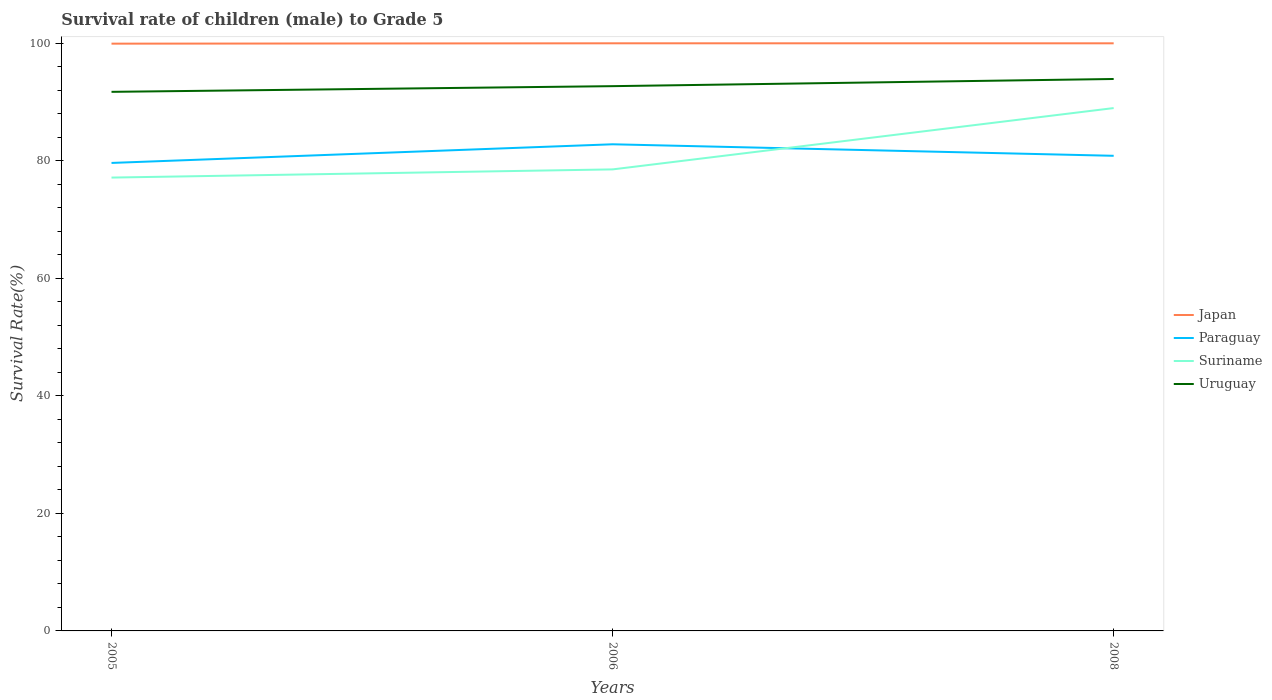How many different coloured lines are there?
Provide a succinct answer. 4. Does the line corresponding to Uruguay intersect with the line corresponding to Japan?
Make the answer very short. No. Is the number of lines equal to the number of legend labels?
Ensure brevity in your answer.  Yes. Across all years, what is the maximum survival rate of male children to grade 5 in Uruguay?
Your answer should be compact. 91.73. In which year was the survival rate of male children to grade 5 in Japan maximum?
Your response must be concise. 2005. What is the total survival rate of male children to grade 5 in Japan in the graph?
Provide a succinct answer. -0.06. What is the difference between the highest and the second highest survival rate of male children to grade 5 in Suriname?
Ensure brevity in your answer.  11.83. What is the difference between the highest and the lowest survival rate of male children to grade 5 in Uruguay?
Provide a succinct answer. 1. Are the values on the major ticks of Y-axis written in scientific E-notation?
Make the answer very short. No. Does the graph contain any zero values?
Ensure brevity in your answer.  No. Does the graph contain grids?
Provide a succinct answer. No. Where does the legend appear in the graph?
Your answer should be compact. Center right. How many legend labels are there?
Offer a very short reply. 4. How are the legend labels stacked?
Ensure brevity in your answer.  Vertical. What is the title of the graph?
Your response must be concise. Survival rate of children (male) to Grade 5. What is the label or title of the Y-axis?
Ensure brevity in your answer.  Survival Rate(%). What is the Survival Rate(%) in Japan in 2005?
Ensure brevity in your answer.  99.93. What is the Survival Rate(%) of Paraguay in 2005?
Offer a terse response. 79.63. What is the Survival Rate(%) of Suriname in 2005?
Give a very brief answer. 77.14. What is the Survival Rate(%) in Uruguay in 2005?
Provide a short and direct response. 91.73. What is the Survival Rate(%) in Japan in 2006?
Give a very brief answer. 99.99. What is the Survival Rate(%) of Paraguay in 2006?
Give a very brief answer. 82.8. What is the Survival Rate(%) of Suriname in 2006?
Your response must be concise. 78.53. What is the Survival Rate(%) in Uruguay in 2006?
Make the answer very short. 92.69. What is the Survival Rate(%) in Japan in 2008?
Provide a short and direct response. 99.98. What is the Survival Rate(%) of Paraguay in 2008?
Give a very brief answer. 80.84. What is the Survival Rate(%) in Suriname in 2008?
Ensure brevity in your answer.  88.96. What is the Survival Rate(%) in Uruguay in 2008?
Provide a short and direct response. 93.92. Across all years, what is the maximum Survival Rate(%) of Japan?
Your response must be concise. 99.99. Across all years, what is the maximum Survival Rate(%) in Paraguay?
Make the answer very short. 82.8. Across all years, what is the maximum Survival Rate(%) in Suriname?
Your answer should be very brief. 88.96. Across all years, what is the maximum Survival Rate(%) of Uruguay?
Give a very brief answer. 93.92. Across all years, what is the minimum Survival Rate(%) in Japan?
Keep it short and to the point. 99.93. Across all years, what is the minimum Survival Rate(%) of Paraguay?
Keep it short and to the point. 79.63. Across all years, what is the minimum Survival Rate(%) in Suriname?
Offer a terse response. 77.14. Across all years, what is the minimum Survival Rate(%) of Uruguay?
Offer a terse response. 91.73. What is the total Survival Rate(%) of Japan in the graph?
Your answer should be very brief. 299.9. What is the total Survival Rate(%) in Paraguay in the graph?
Your response must be concise. 243.28. What is the total Survival Rate(%) of Suriname in the graph?
Offer a very short reply. 244.63. What is the total Survival Rate(%) in Uruguay in the graph?
Keep it short and to the point. 278.34. What is the difference between the Survival Rate(%) of Japan in 2005 and that in 2006?
Your answer should be very brief. -0.06. What is the difference between the Survival Rate(%) in Paraguay in 2005 and that in 2006?
Offer a terse response. -3.17. What is the difference between the Survival Rate(%) in Suriname in 2005 and that in 2006?
Give a very brief answer. -1.39. What is the difference between the Survival Rate(%) of Uruguay in 2005 and that in 2006?
Your response must be concise. -0.97. What is the difference between the Survival Rate(%) of Japan in 2005 and that in 2008?
Your answer should be compact. -0.06. What is the difference between the Survival Rate(%) in Paraguay in 2005 and that in 2008?
Make the answer very short. -1.21. What is the difference between the Survival Rate(%) in Suriname in 2005 and that in 2008?
Your answer should be compact. -11.83. What is the difference between the Survival Rate(%) in Uruguay in 2005 and that in 2008?
Provide a succinct answer. -2.19. What is the difference between the Survival Rate(%) in Japan in 2006 and that in 2008?
Your answer should be very brief. 0. What is the difference between the Survival Rate(%) of Paraguay in 2006 and that in 2008?
Your answer should be very brief. 1.96. What is the difference between the Survival Rate(%) of Suriname in 2006 and that in 2008?
Give a very brief answer. -10.43. What is the difference between the Survival Rate(%) of Uruguay in 2006 and that in 2008?
Make the answer very short. -1.22. What is the difference between the Survival Rate(%) of Japan in 2005 and the Survival Rate(%) of Paraguay in 2006?
Your response must be concise. 17.12. What is the difference between the Survival Rate(%) of Japan in 2005 and the Survival Rate(%) of Suriname in 2006?
Provide a succinct answer. 21.4. What is the difference between the Survival Rate(%) of Japan in 2005 and the Survival Rate(%) of Uruguay in 2006?
Your response must be concise. 7.23. What is the difference between the Survival Rate(%) of Paraguay in 2005 and the Survival Rate(%) of Suriname in 2006?
Offer a very short reply. 1.1. What is the difference between the Survival Rate(%) of Paraguay in 2005 and the Survival Rate(%) of Uruguay in 2006?
Give a very brief answer. -13.06. What is the difference between the Survival Rate(%) of Suriname in 2005 and the Survival Rate(%) of Uruguay in 2006?
Your answer should be compact. -15.55. What is the difference between the Survival Rate(%) in Japan in 2005 and the Survival Rate(%) in Paraguay in 2008?
Make the answer very short. 19.08. What is the difference between the Survival Rate(%) in Japan in 2005 and the Survival Rate(%) in Suriname in 2008?
Your answer should be compact. 10.96. What is the difference between the Survival Rate(%) in Japan in 2005 and the Survival Rate(%) in Uruguay in 2008?
Your response must be concise. 6.01. What is the difference between the Survival Rate(%) of Paraguay in 2005 and the Survival Rate(%) of Suriname in 2008?
Ensure brevity in your answer.  -9.33. What is the difference between the Survival Rate(%) of Paraguay in 2005 and the Survival Rate(%) of Uruguay in 2008?
Your answer should be compact. -14.29. What is the difference between the Survival Rate(%) in Suriname in 2005 and the Survival Rate(%) in Uruguay in 2008?
Ensure brevity in your answer.  -16.78. What is the difference between the Survival Rate(%) in Japan in 2006 and the Survival Rate(%) in Paraguay in 2008?
Your response must be concise. 19.14. What is the difference between the Survival Rate(%) in Japan in 2006 and the Survival Rate(%) in Suriname in 2008?
Your answer should be very brief. 11.02. What is the difference between the Survival Rate(%) in Japan in 2006 and the Survival Rate(%) in Uruguay in 2008?
Your answer should be compact. 6.07. What is the difference between the Survival Rate(%) of Paraguay in 2006 and the Survival Rate(%) of Suriname in 2008?
Make the answer very short. -6.16. What is the difference between the Survival Rate(%) in Paraguay in 2006 and the Survival Rate(%) in Uruguay in 2008?
Make the answer very short. -11.11. What is the difference between the Survival Rate(%) of Suriname in 2006 and the Survival Rate(%) of Uruguay in 2008?
Offer a very short reply. -15.38. What is the average Survival Rate(%) in Japan per year?
Ensure brevity in your answer.  99.97. What is the average Survival Rate(%) of Paraguay per year?
Give a very brief answer. 81.09. What is the average Survival Rate(%) of Suriname per year?
Provide a short and direct response. 81.54. What is the average Survival Rate(%) in Uruguay per year?
Give a very brief answer. 92.78. In the year 2005, what is the difference between the Survival Rate(%) of Japan and Survival Rate(%) of Paraguay?
Your answer should be very brief. 20.3. In the year 2005, what is the difference between the Survival Rate(%) of Japan and Survival Rate(%) of Suriname?
Keep it short and to the point. 22.79. In the year 2005, what is the difference between the Survival Rate(%) of Japan and Survival Rate(%) of Uruguay?
Ensure brevity in your answer.  8.2. In the year 2005, what is the difference between the Survival Rate(%) in Paraguay and Survival Rate(%) in Suriname?
Give a very brief answer. 2.49. In the year 2005, what is the difference between the Survival Rate(%) of Paraguay and Survival Rate(%) of Uruguay?
Give a very brief answer. -12.1. In the year 2005, what is the difference between the Survival Rate(%) in Suriname and Survival Rate(%) in Uruguay?
Give a very brief answer. -14.59. In the year 2006, what is the difference between the Survival Rate(%) in Japan and Survival Rate(%) in Paraguay?
Give a very brief answer. 17.18. In the year 2006, what is the difference between the Survival Rate(%) in Japan and Survival Rate(%) in Suriname?
Give a very brief answer. 21.46. In the year 2006, what is the difference between the Survival Rate(%) of Japan and Survival Rate(%) of Uruguay?
Offer a very short reply. 7.29. In the year 2006, what is the difference between the Survival Rate(%) in Paraguay and Survival Rate(%) in Suriname?
Offer a terse response. 4.27. In the year 2006, what is the difference between the Survival Rate(%) in Paraguay and Survival Rate(%) in Uruguay?
Ensure brevity in your answer.  -9.89. In the year 2006, what is the difference between the Survival Rate(%) in Suriname and Survival Rate(%) in Uruguay?
Keep it short and to the point. -14.16. In the year 2008, what is the difference between the Survival Rate(%) in Japan and Survival Rate(%) in Paraguay?
Give a very brief answer. 19.14. In the year 2008, what is the difference between the Survival Rate(%) of Japan and Survival Rate(%) of Suriname?
Provide a succinct answer. 11.02. In the year 2008, what is the difference between the Survival Rate(%) in Japan and Survival Rate(%) in Uruguay?
Give a very brief answer. 6.07. In the year 2008, what is the difference between the Survival Rate(%) of Paraguay and Survival Rate(%) of Suriname?
Ensure brevity in your answer.  -8.12. In the year 2008, what is the difference between the Survival Rate(%) of Paraguay and Survival Rate(%) of Uruguay?
Ensure brevity in your answer.  -13.07. In the year 2008, what is the difference between the Survival Rate(%) in Suriname and Survival Rate(%) in Uruguay?
Provide a short and direct response. -4.95. What is the ratio of the Survival Rate(%) in Japan in 2005 to that in 2006?
Provide a short and direct response. 1. What is the ratio of the Survival Rate(%) of Paraguay in 2005 to that in 2006?
Provide a succinct answer. 0.96. What is the ratio of the Survival Rate(%) in Suriname in 2005 to that in 2006?
Your answer should be compact. 0.98. What is the ratio of the Survival Rate(%) of Uruguay in 2005 to that in 2006?
Ensure brevity in your answer.  0.99. What is the ratio of the Survival Rate(%) in Suriname in 2005 to that in 2008?
Offer a terse response. 0.87. What is the ratio of the Survival Rate(%) in Uruguay in 2005 to that in 2008?
Provide a short and direct response. 0.98. What is the ratio of the Survival Rate(%) of Paraguay in 2006 to that in 2008?
Your answer should be compact. 1.02. What is the ratio of the Survival Rate(%) of Suriname in 2006 to that in 2008?
Offer a very short reply. 0.88. What is the difference between the highest and the second highest Survival Rate(%) in Japan?
Your response must be concise. 0. What is the difference between the highest and the second highest Survival Rate(%) in Paraguay?
Provide a short and direct response. 1.96. What is the difference between the highest and the second highest Survival Rate(%) in Suriname?
Your response must be concise. 10.43. What is the difference between the highest and the second highest Survival Rate(%) of Uruguay?
Provide a succinct answer. 1.22. What is the difference between the highest and the lowest Survival Rate(%) of Japan?
Provide a short and direct response. 0.06. What is the difference between the highest and the lowest Survival Rate(%) in Paraguay?
Keep it short and to the point. 3.17. What is the difference between the highest and the lowest Survival Rate(%) of Suriname?
Your answer should be compact. 11.83. What is the difference between the highest and the lowest Survival Rate(%) of Uruguay?
Offer a terse response. 2.19. 